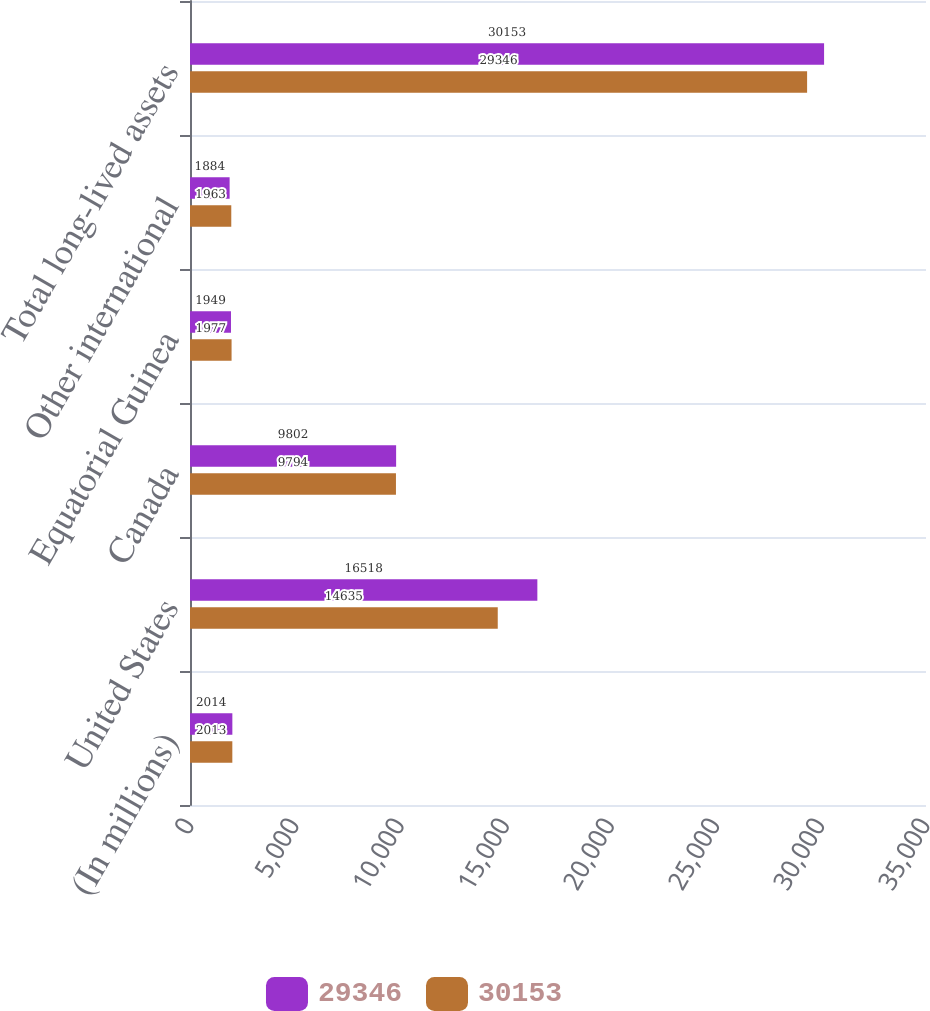Convert chart. <chart><loc_0><loc_0><loc_500><loc_500><stacked_bar_chart><ecel><fcel>(In millions)<fcel>United States<fcel>Canada<fcel>Equatorial Guinea<fcel>Other international<fcel>Total long-lived assets<nl><fcel>29346<fcel>2014<fcel>16518<fcel>9802<fcel>1949<fcel>1884<fcel>30153<nl><fcel>30153<fcel>2013<fcel>14635<fcel>9794<fcel>1977<fcel>1963<fcel>29346<nl></chart> 